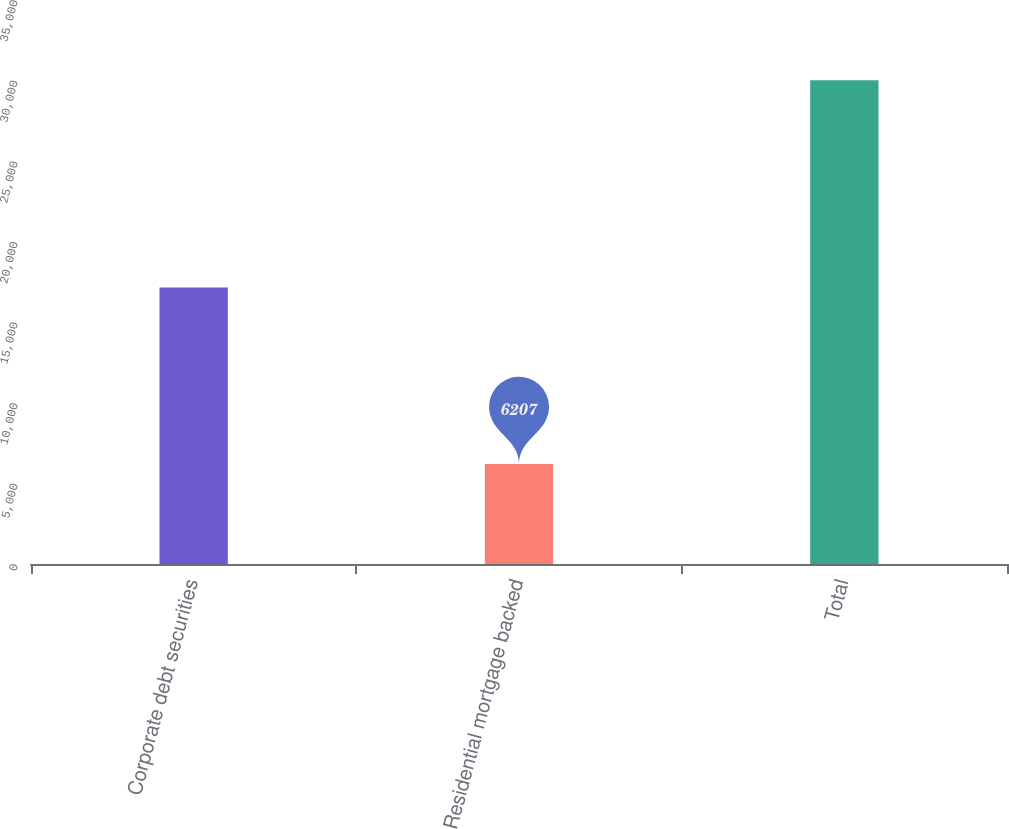Convert chart. <chart><loc_0><loc_0><loc_500><loc_500><bar_chart><fcel>Corporate debt securities<fcel>Residential mortgage backed<fcel>Total<nl><fcel>17165<fcel>6207<fcel>30027<nl></chart> 